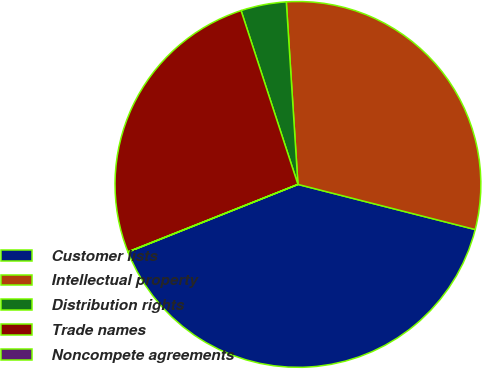Convert chart to OTSL. <chart><loc_0><loc_0><loc_500><loc_500><pie_chart><fcel>Customer lists<fcel>Intellectual property<fcel>Distribution rights<fcel>Trade names<fcel>Noncompete agreements<nl><fcel>40.0%<fcel>29.98%<fcel>4.02%<fcel>25.98%<fcel>0.02%<nl></chart> 